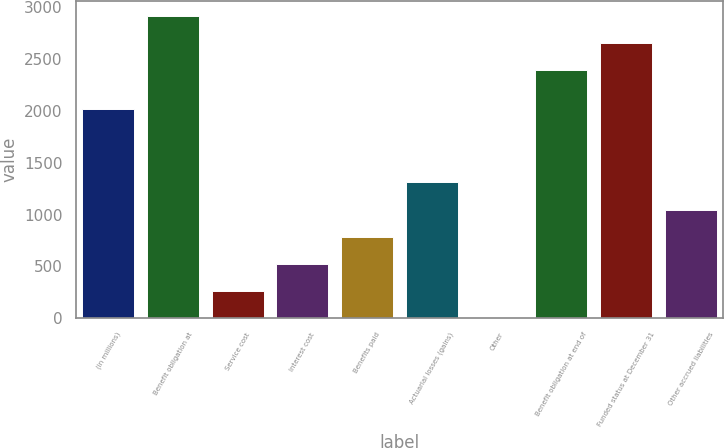<chart> <loc_0><loc_0><loc_500><loc_500><bar_chart><fcel>(in millions)<fcel>Benefit obligation at<fcel>Service cost<fcel>Interest cost<fcel>Benefits paid<fcel>Actuarial losses (gains)<fcel>Other<fcel>Benefit obligation at end of<fcel>Funded status at December 31<fcel>Other accrued liabilities<nl><fcel>2015<fcel>2913.4<fcel>266.7<fcel>527.4<fcel>788.1<fcel>1309.5<fcel>6<fcel>2392<fcel>2652.7<fcel>1048.8<nl></chart> 